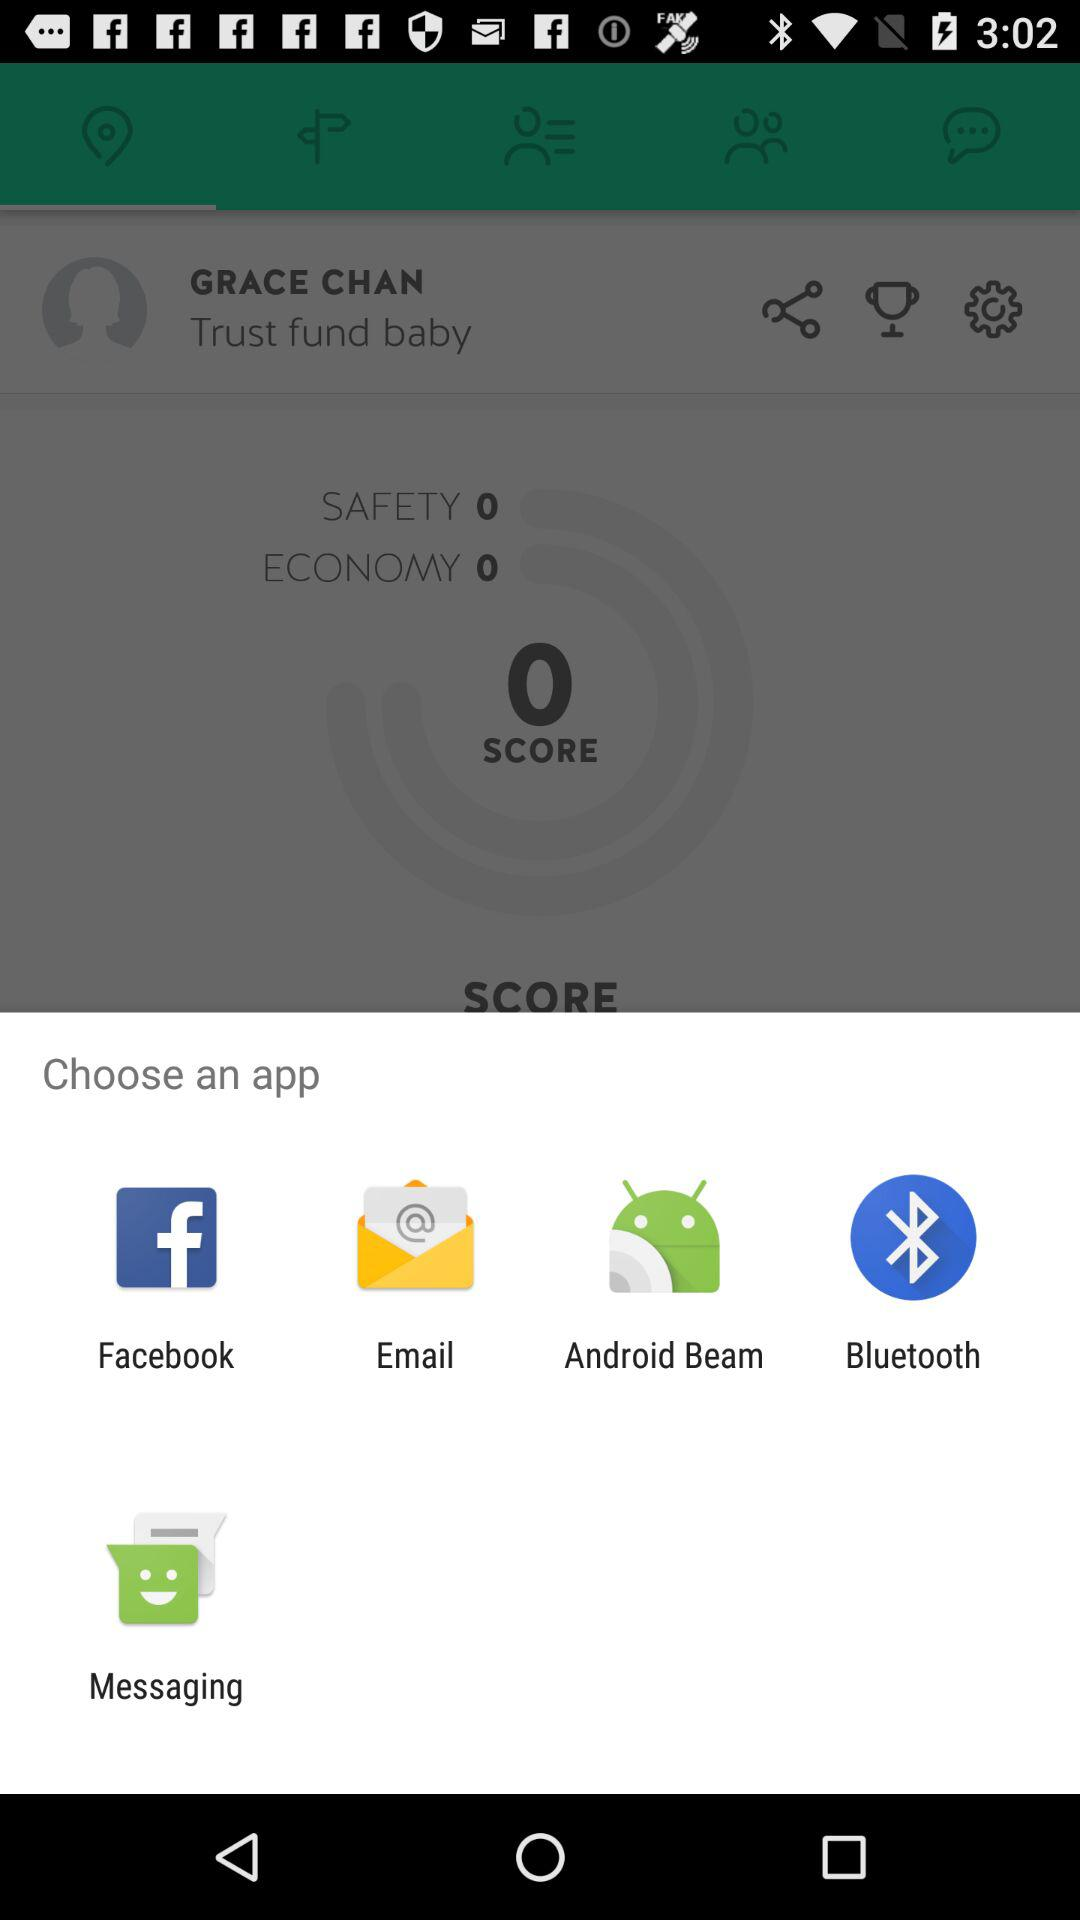What is the name of the user? The name of the user is Grace Chan. 